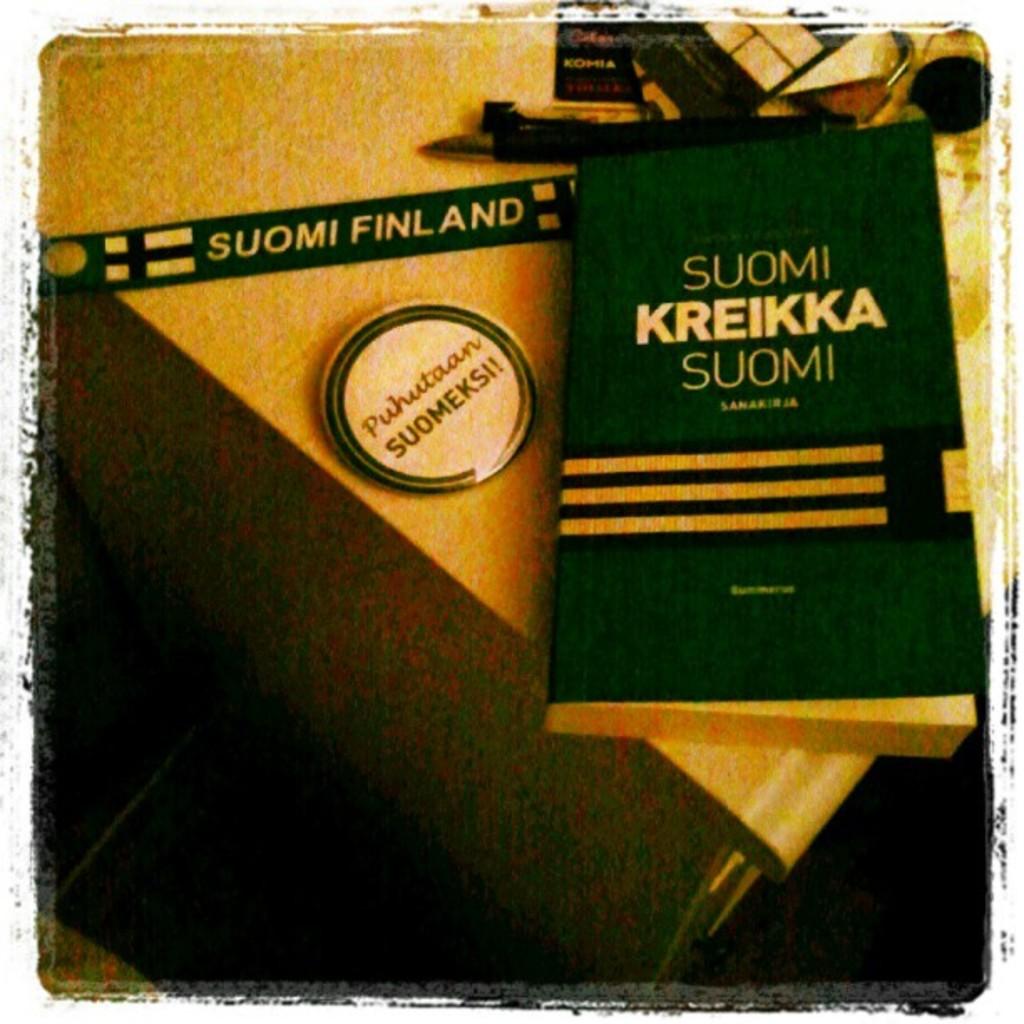What is the title of the book?
Ensure brevity in your answer.  Suomi kreikka suomi. What country is on this photo?
Keep it short and to the point. Finland. 